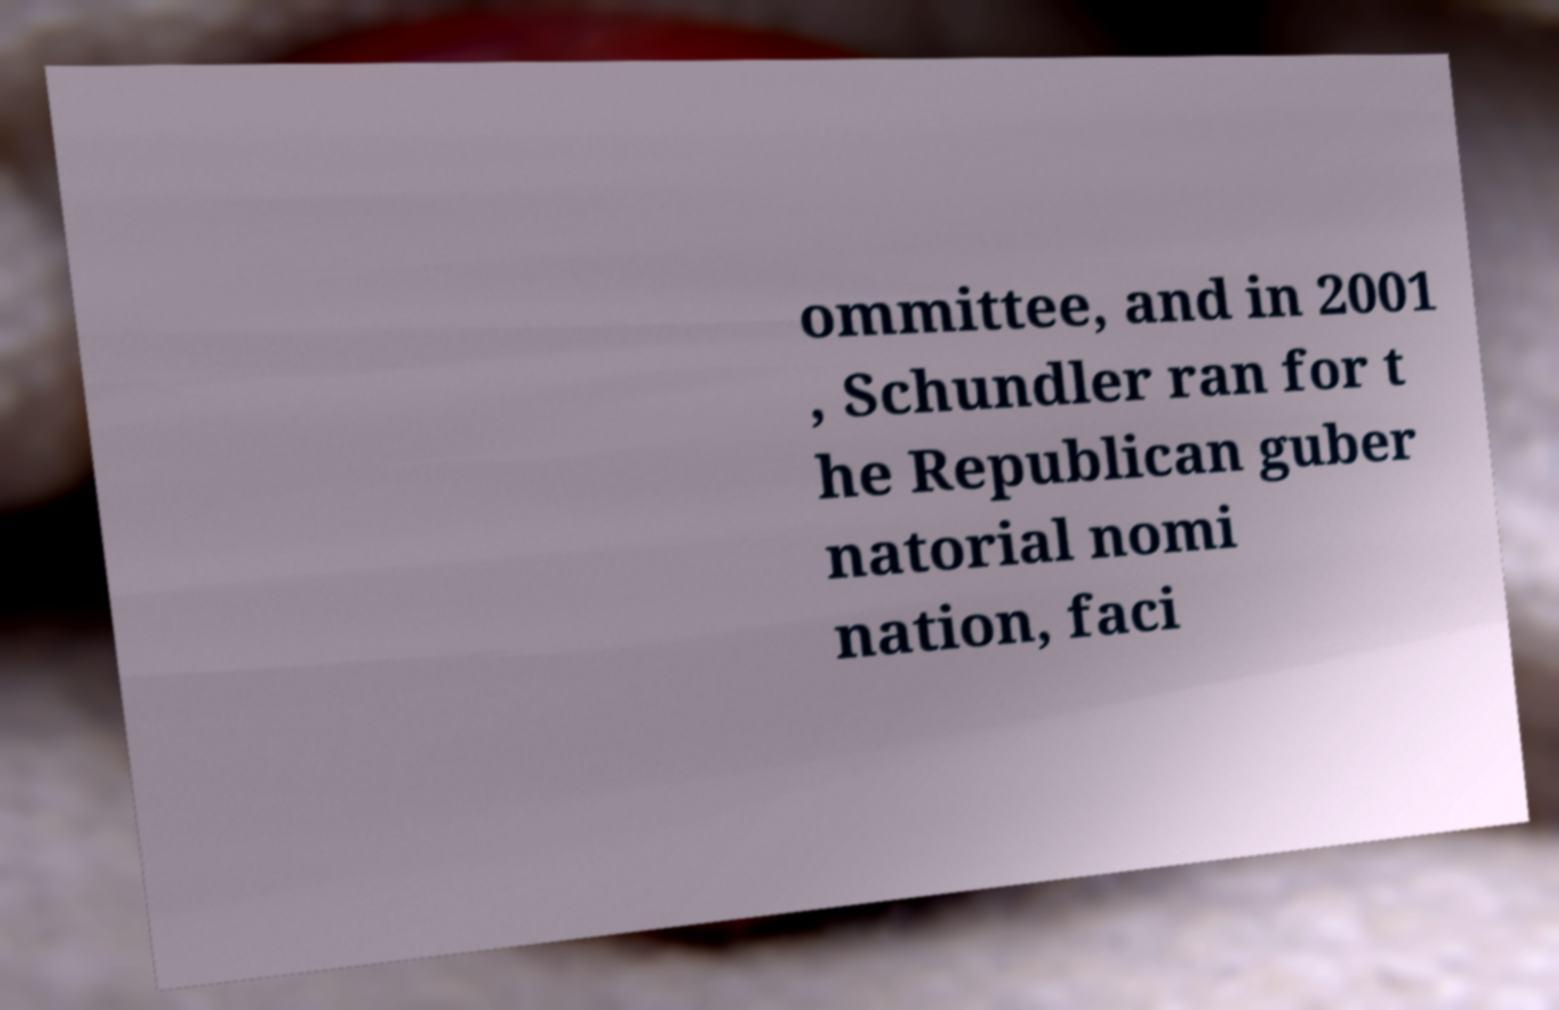Please identify and transcribe the text found in this image. ommittee, and in 2001 , Schundler ran for t he Republican guber natorial nomi nation, faci 